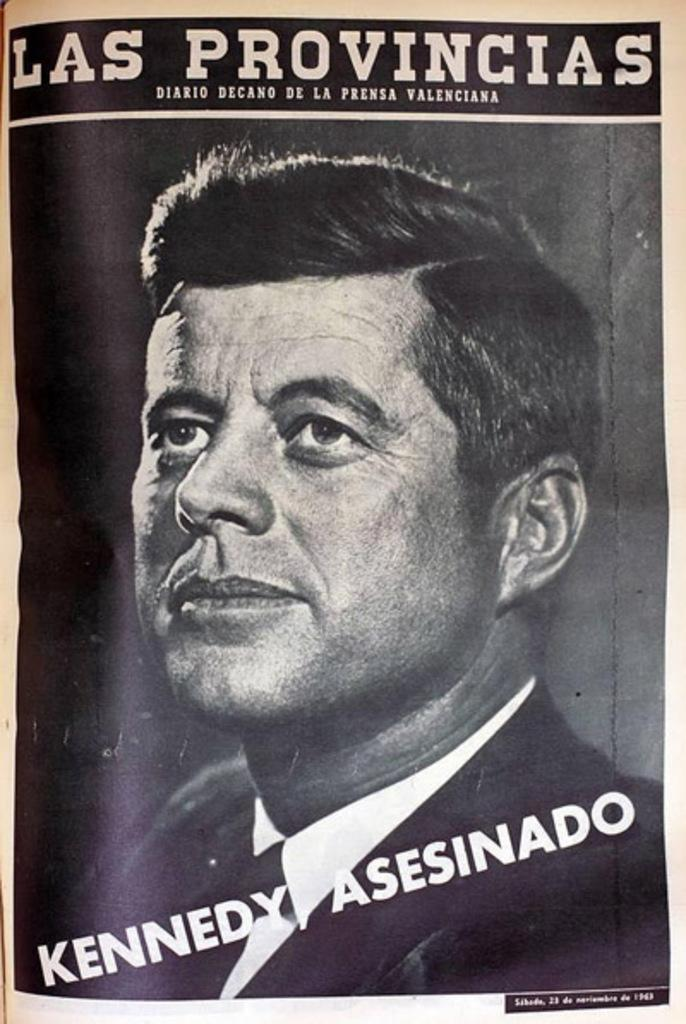<image>
Render a clear and concise summary of the photo. A magazine cover with President Kennedy on it. 